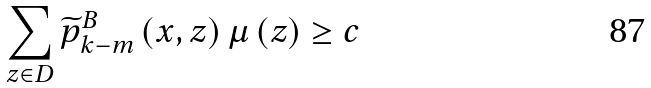<formula> <loc_0><loc_0><loc_500><loc_500>\sum _ { z \in D } \widetilde { p } _ { k - m } ^ { B } \left ( x , z \right ) \mu \left ( z \right ) \geq c</formula> 